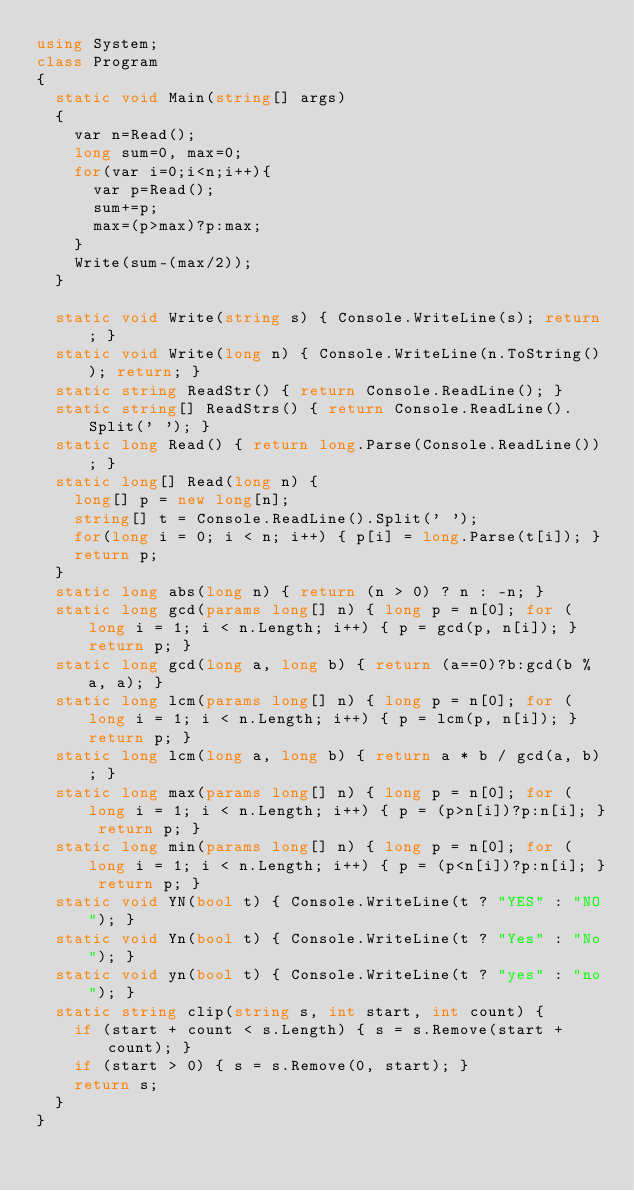<code> <loc_0><loc_0><loc_500><loc_500><_C#_>using System;
class Program
{
  static void Main(string[] args)
  {
    var n=Read();
    long sum=0, max=0;
    for(var i=0;i<n;i++){
      var p=Read();
      sum+=p;
      max=(p>max)?p:max;
    }
    Write(sum-(max/2));
  }

  static void Write(string s) { Console.WriteLine(s); return; }
  static void Write(long n) { Console.WriteLine(n.ToString()); return; }
  static string ReadStr() { return Console.ReadLine(); }
  static string[] ReadStrs() { return Console.ReadLine().Split(' '); }
  static long Read() { return long.Parse(Console.ReadLine()); }
  static long[] Read(long n) {
    long[] p = new long[n];
    string[] t = Console.ReadLine().Split(' ');
    for(long i = 0; i < n; i++) { p[i] = long.Parse(t[i]); }
    return p;
  }
  static long abs(long n) { return (n > 0) ? n : -n; }
  static long gcd(params long[] n) { long p = n[0]; for (long i = 1; i < n.Length; i++) { p = gcd(p, n[i]); } return p; }
  static long gcd(long a, long b) { return (a==0)?b:gcd(b % a, a); }
  static long lcm(params long[] n) { long p = n[0]; for (long i = 1; i < n.Length; i++) { p = lcm(p, n[i]); } return p; }
  static long lcm(long a, long b) { return a * b / gcd(a, b); }
  static long max(params long[] n) { long p = n[0]; for (long i = 1; i < n.Length; i++) { p = (p>n[i])?p:n[i]; } return p; }
  static long min(params long[] n) { long p = n[0]; for (long i = 1; i < n.Length; i++) { p = (p<n[i])?p:n[i]; } return p; }
  static void YN(bool t) { Console.WriteLine(t ? "YES" : "NO"); }
  static void Yn(bool t) { Console.WriteLine(t ? "Yes" : "No"); }
  static void yn(bool t) { Console.WriteLine(t ? "yes" : "no"); }
  static string clip(string s, int start, int count) {
    if (start + count < s.Length) { s = s.Remove(start + count); }
    if (start > 0) { s = s.Remove(0, start); }
    return s;
  }
}
</code> 